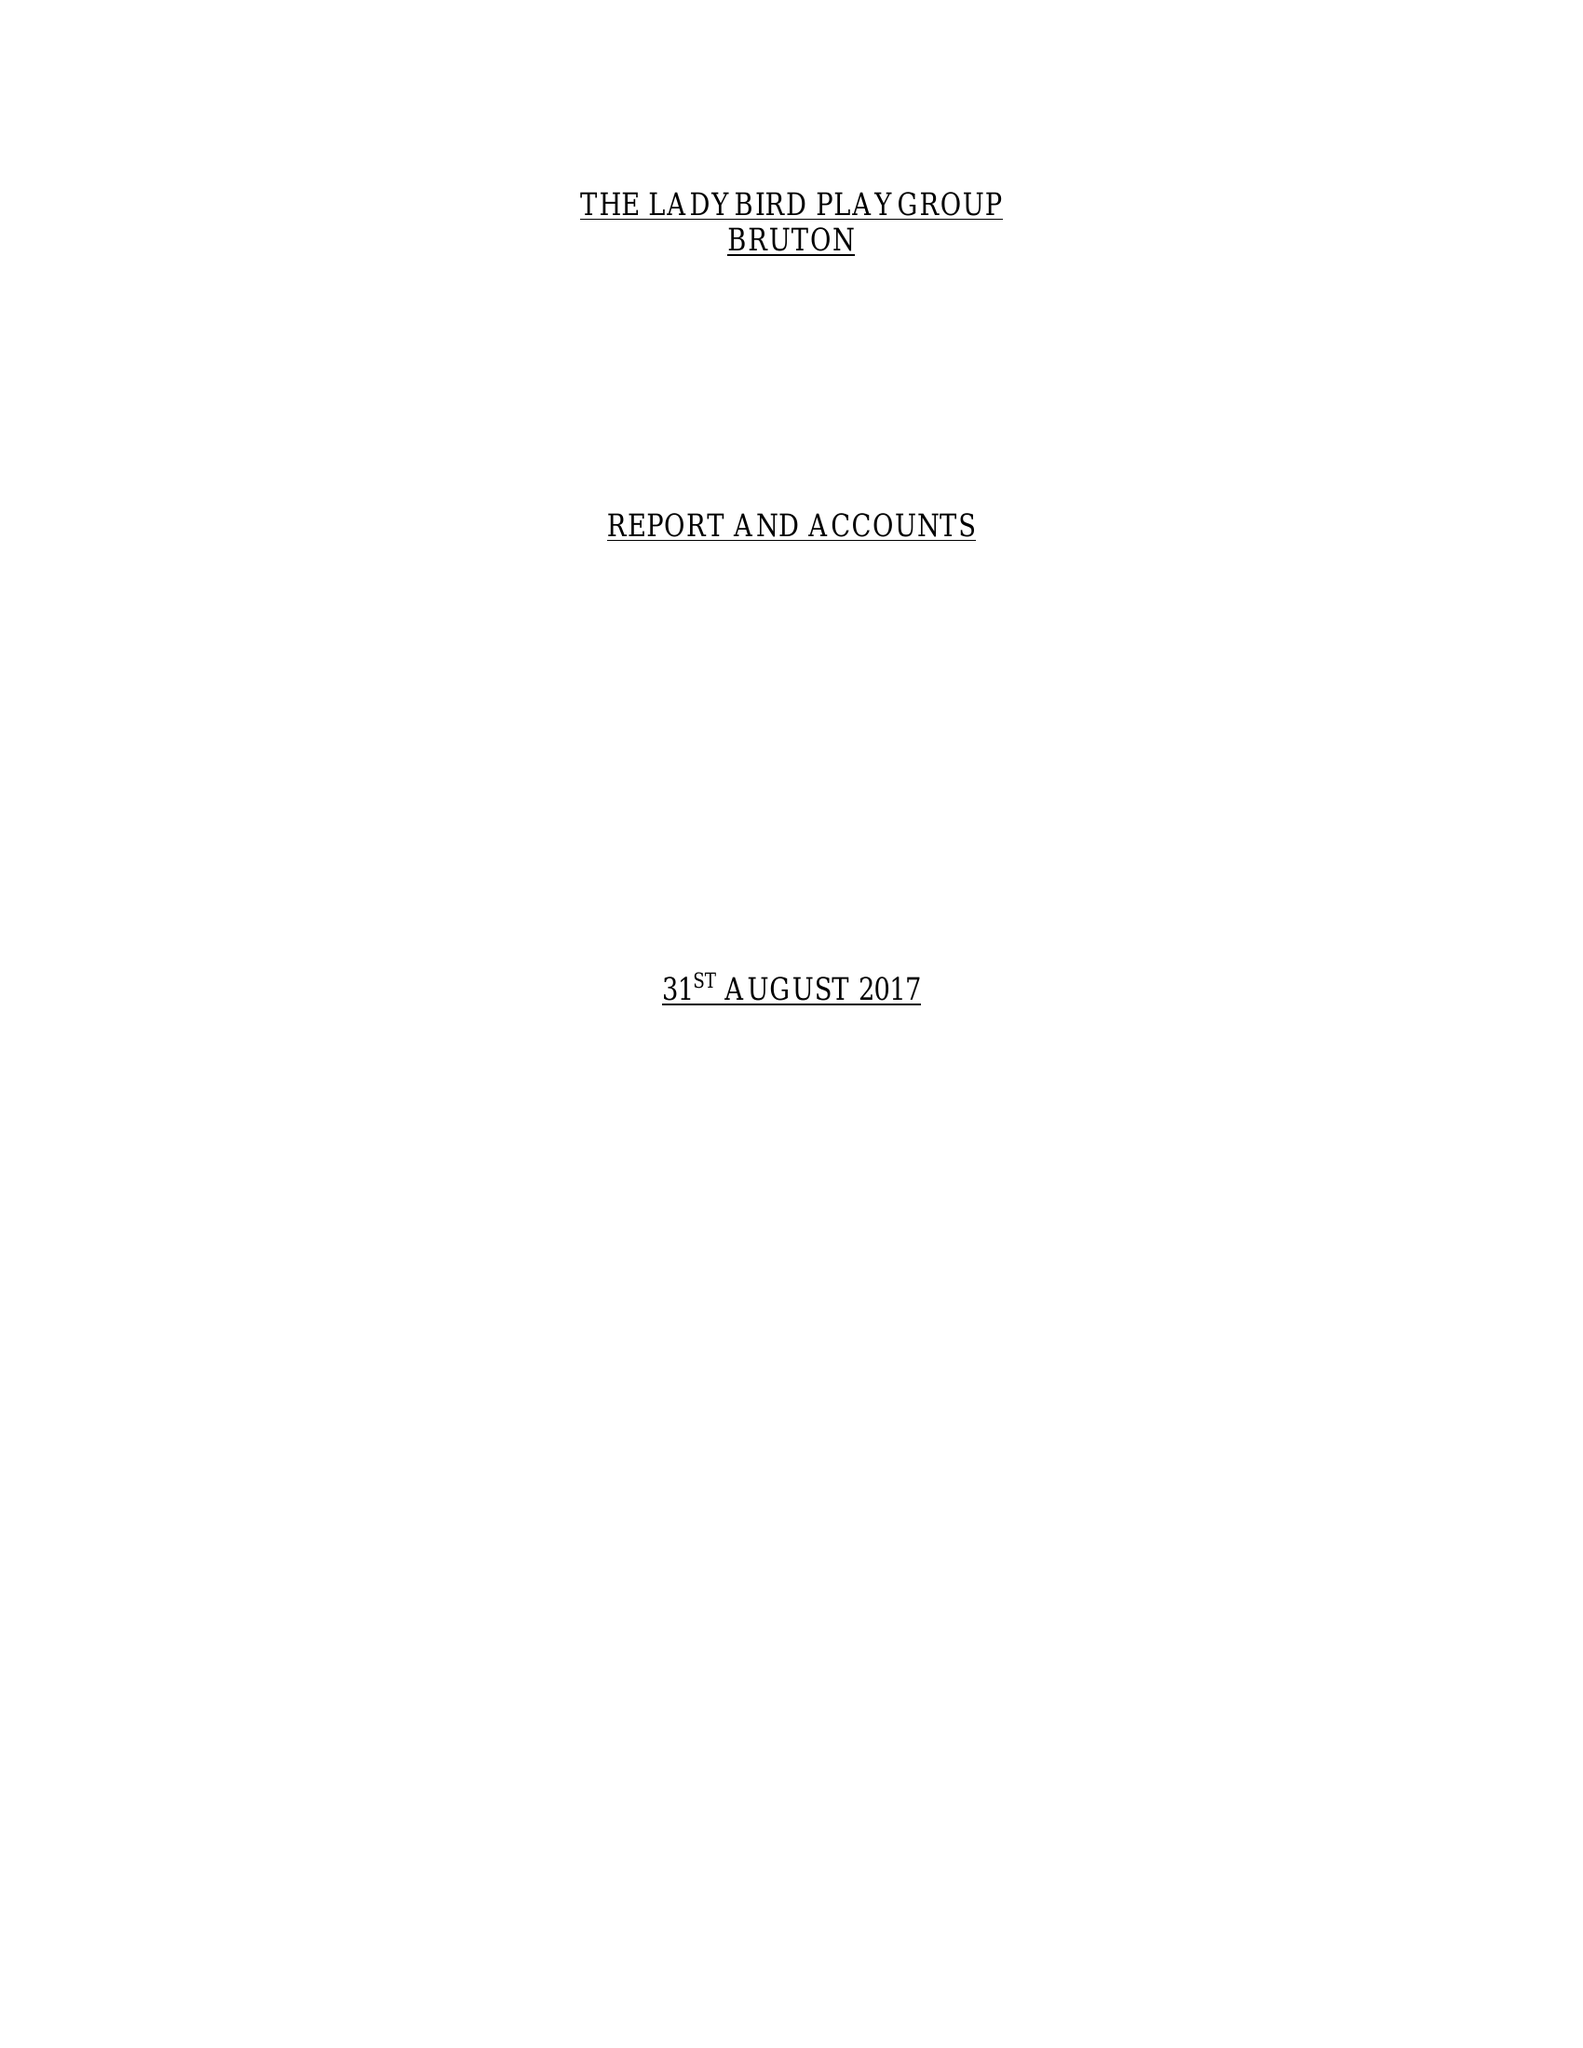What is the value for the address__postcode?
Answer the question using a single word or phrase. BA10  